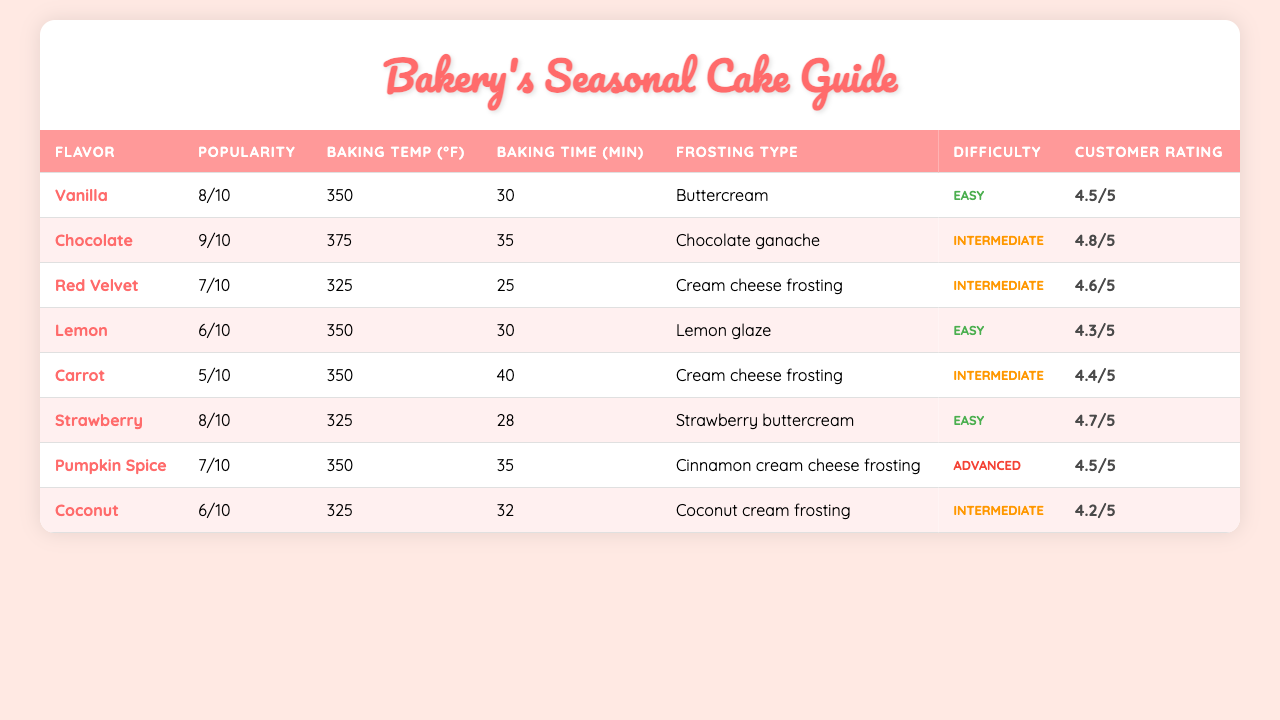What is the baking temperature for the Chocolate cake? Referring to the table, the baking temperature for the Chocolate cake is 375°F.
Answer: 375°F Which cake has the highest customer rating? Looking through the customer ratings, the highest rating is 4.8, which corresponds to the Chocolate cake.
Answer: Chocolate What is the average baking time for all cakes? To find the average baking time, we add all the baking times (30 + 35 + 25 + 30 + 40 + 28 + 35 + 32) =  285 minutes. Dividing by the number of cakes (8), the average is 285/8 = 35.625.
Answer: 35.63 minutes Is Strawberry cake easier to bake than Coconut cake? The difficulty level for Strawberry cake is easy and for Coconut cake is intermediate. Since "easy" is less challenging than "intermediate", the statement is true.
Answer: Yes Which season is most popular for the Vanilla cake? The table does not explicitly state the seasons for each cake. However, we know Vanilla is made with lemon zest and fresh strawberries, which are spring ingredients, indicating spring could be popular for Vanilla.
Answer: Spring (implied) What is the difference in popularity score between Carrot and Lemon cakes? The popularity score for Carrot cake is 5 and for Lemon cake is 6. The difference is 6 - 5 = 1.
Answer: 1 Which cakes are baked at a temperature of 350°F? From the table, the cakes baked at 350°F are Vanilla, Lemon, Pumpkin Spice, and Coconut.
Answer: Vanilla, Lemon, Pumpkin Spice, Coconut Is it true that all cakes have a baking time less than 40 minutes? By checking the baking times, Carrot cake has a baking time of 40 minutes. Therefore, not all baking times are under 40 minutes, making the statement false.
Answer: No What is the frosting type for the Red Velvet cake? The table indicates that the frosting type for Red Velvet cake is Cream cheese frosting.
Answer: Cream cheese frosting How many cakes are rated above 4.5? The cakes with ratings above 4.5 are Chocolate (4.8), Strawberry (4.7), Red Velvet (4.6), and Vanilla (4.5), totaling 4 cakes rated above 4.5.
Answer: 3 